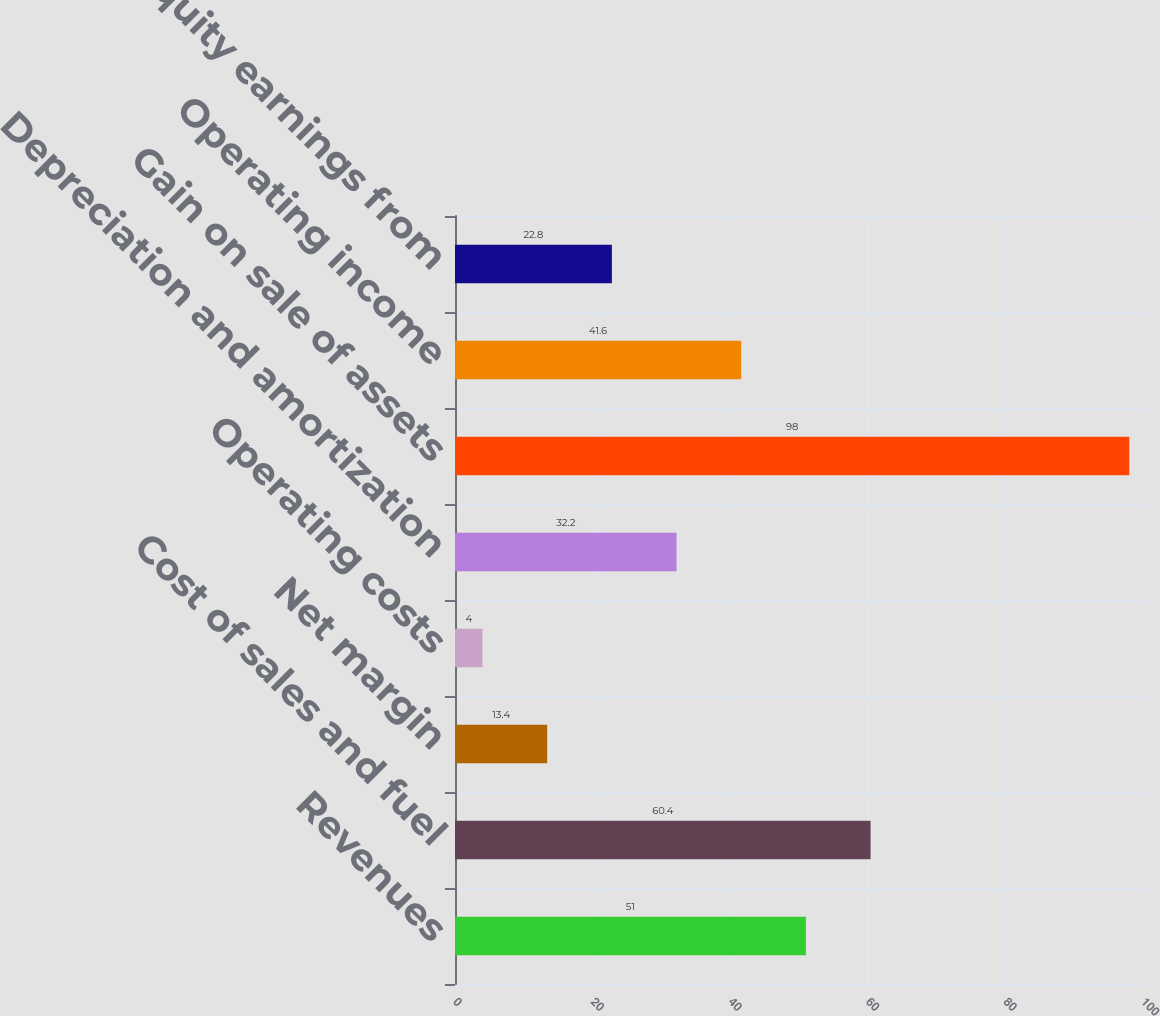Convert chart. <chart><loc_0><loc_0><loc_500><loc_500><bar_chart><fcel>Revenues<fcel>Cost of sales and fuel<fcel>Net margin<fcel>Operating costs<fcel>Depreciation and amortization<fcel>Gain on sale of assets<fcel>Operating income<fcel>Equity earnings from<nl><fcel>51<fcel>60.4<fcel>13.4<fcel>4<fcel>32.2<fcel>98<fcel>41.6<fcel>22.8<nl></chart> 